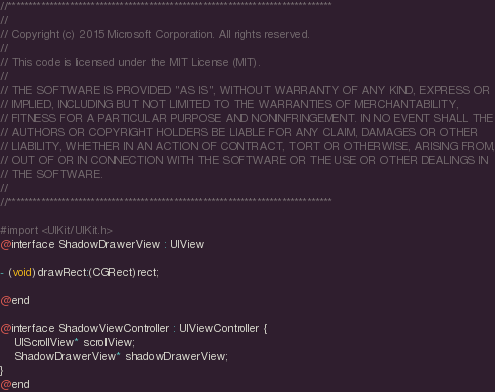Convert code to text. <code><loc_0><loc_0><loc_500><loc_500><_C_>//******************************************************************************
//
// Copyright (c) 2015 Microsoft Corporation. All rights reserved.
//
// This code is licensed under the MIT License (MIT).
//
// THE SOFTWARE IS PROVIDED "AS IS", WITHOUT WARRANTY OF ANY KIND, EXPRESS OR
// IMPLIED, INCLUDING BUT NOT LIMITED TO THE WARRANTIES OF MERCHANTABILITY,
// FITNESS FOR A PARTICULAR PURPOSE AND NONINFRINGEMENT. IN NO EVENT SHALL THE
// AUTHORS OR COPYRIGHT HOLDERS BE LIABLE FOR ANY CLAIM, DAMAGES OR OTHER
// LIABILITY, WHETHER IN AN ACTION OF CONTRACT, TORT OR OTHERWISE, ARISING FROM,
// OUT OF OR IN CONNECTION WITH THE SOFTWARE OR THE USE OR OTHER DEALINGS IN
// THE SOFTWARE.
//
//******************************************************************************

#import <UIKit/UIKit.h>
@interface ShadowDrawerView : UIView

- (void)drawRect:(CGRect)rect;

@end

@interface ShadowViewController : UIViewController {
    UIScrollView* scrollView;
    ShadowDrawerView* shadowDrawerView;
}
@end
</code> 